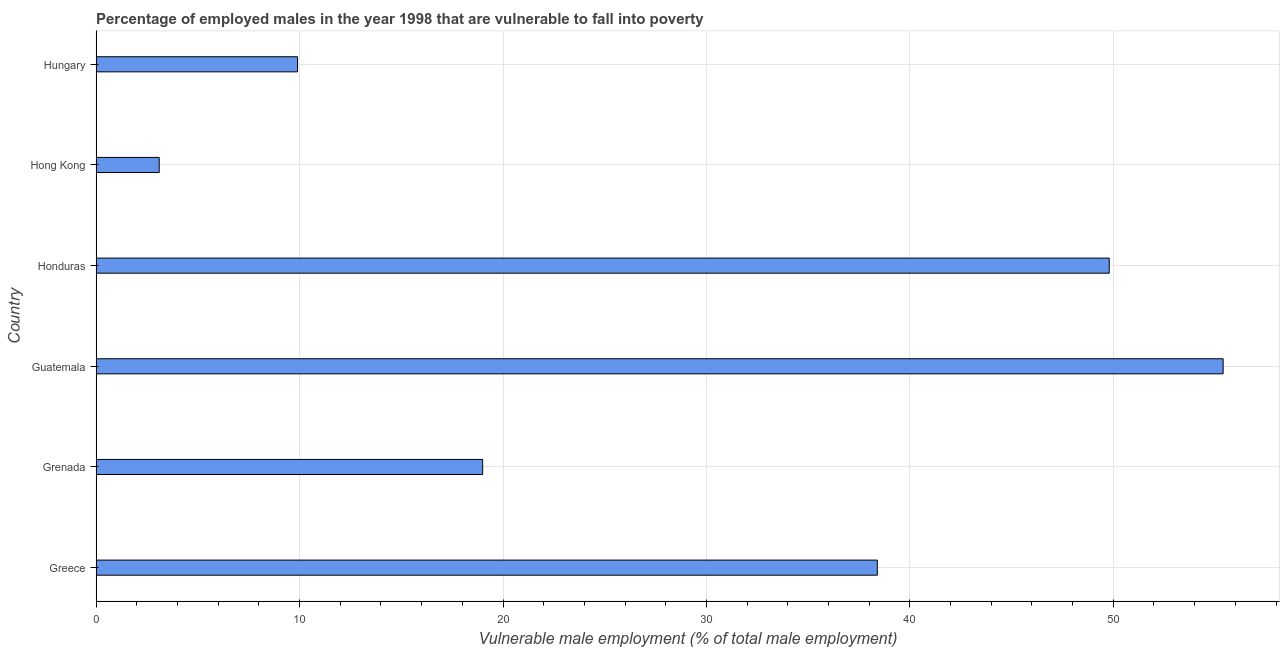Does the graph contain grids?
Offer a very short reply. Yes. What is the title of the graph?
Keep it short and to the point. Percentage of employed males in the year 1998 that are vulnerable to fall into poverty. What is the label or title of the X-axis?
Provide a short and direct response. Vulnerable male employment (% of total male employment). What is the percentage of employed males who are vulnerable to fall into poverty in Guatemala?
Offer a terse response. 55.4. Across all countries, what is the maximum percentage of employed males who are vulnerable to fall into poverty?
Provide a succinct answer. 55.4. Across all countries, what is the minimum percentage of employed males who are vulnerable to fall into poverty?
Make the answer very short. 3.1. In which country was the percentage of employed males who are vulnerable to fall into poverty maximum?
Provide a short and direct response. Guatemala. In which country was the percentage of employed males who are vulnerable to fall into poverty minimum?
Provide a succinct answer. Hong Kong. What is the sum of the percentage of employed males who are vulnerable to fall into poverty?
Provide a succinct answer. 175.6. What is the difference between the percentage of employed males who are vulnerable to fall into poverty in Grenada and Guatemala?
Make the answer very short. -36.4. What is the average percentage of employed males who are vulnerable to fall into poverty per country?
Your response must be concise. 29.27. What is the median percentage of employed males who are vulnerable to fall into poverty?
Keep it short and to the point. 28.7. In how many countries, is the percentage of employed males who are vulnerable to fall into poverty greater than 54 %?
Your answer should be compact. 1. What is the ratio of the percentage of employed males who are vulnerable to fall into poverty in Honduras to that in Hong Kong?
Provide a short and direct response. 16.07. What is the difference between the highest and the lowest percentage of employed males who are vulnerable to fall into poverty?
Give a very brief answer. 52.3. How many bars are there?
Keep it short and to the point. 6. Are all the bars in the graph horizontal?
Your answer should be very brief. Yes. How many countries are there in the graph?
Make the answer very short. 6. What is the Vulnerable male employment (% of total male employment) in Greece?
Offer a terse response. 38.4. What is the Vulnerable male employment (% of total male employment) in Guatemala?
Keep it short and to the point. 55.4. What is the Vulnerable male employment (% of total male employment) of Honduras?
Give a very brief answer. 49.8. What is the Vulnerable male employment (% of total male employment) of Hong Kong?
Ensure brevity in your answer.  3.1. What is the Vulnerable male employment (% of total male employment) of Hungary?
Make the answer very short. 9.9. What is the difference between the Vulnerable male employment (% of total male employment) in Greece and Guatemala?
Your response must be concise. -17. What is the difference between the Vulnerable male employment (% of total male employment) in Greece and Honduras?
Provide a short and direct response. -11.4. What is the difference between the Vulnerable male employment (% of total male employment) in Greece and Hong Kong?
Your answer should be compact. 35.3. What is the difference between the Vulnerable male employment (% of total male employment) in Grenada and Guatemala?
Provide a succinct answer. -36.4. What is the difference between the Vulnerable male employment (% of total male employment) in Grenada and Honduras?
Offer a very short reply. -30.8. What is the difference between the Vulnerable male employment (% of total male employment) in Grenada and Hong Kong?
Offer a very short reply. 15.9. What is the difference between the Vulnerable male employment (% of total male employment) in Guatemala and Honduras?
Ensure brevity in your answer.  5.6. What is the difference between the Vulnerable male employment (% of total male employment) in Guatemala and Hong Kong?
Make the answer very short. 52.3. What is the difference between the Vulnerable male employment (% of total male employment) in Guatemala and Hungary?
Provide a succinct answer. 45.5. What is the difference between the Vulnerable male employment (% of total male employment) in Honduras and Hong Kong?
Provide a short and direct response. 46.7. What is the difference between the Vulnerable male employment (% of total male employment) in Honduras and Hungary?
Your answer should be compact. 39.9. What is the ratio of the Vulnerable male employment (% of total male employment) in Greece to that in Grenada?
Provide a succinct answer. 2.02. What is the ratio of the Vulnerable male employment (% of total male employment) in Greece to that in Guatemala?
Provide a succinct answer. 0.69. What is the ratio of the Vulnerable male employment (% of total male employment) in Greece to that in Honduras?
Your answer should be very brief. 0.77. What is the ratio of the Vulnerable male employment (% of total male employment) in Greece to that in Hong Kong?
Make the answer very short. 12.39. What is the ratio of the Vulnerable male employment (% of total male employment) in Greece to that in Hungary?
Keep it short and to the point. 3.88. What is the ratio of the Vulnerable male employment (% of total male employment) in Grenada to that in Guatemala?
Offer a terse response. 0.34. What is the ratio of the Vulnerable male employment (% of total male employment) in Grenada to that in Honduras?
Provide a succinct answer. 0.38. What is the ratio of the Vulnerable male employment (% of total male employment) in Grenada to that in Hong Kong?
Your answer should be very brief. 6.13. What is the ratio of the Vulnerable male employment (% of total male employment) in Grenada to that in Hungary?
Make the answer very short. 1.92. What is the ratio of the Vulnerable male employment (% of total male employment) in Guatemala to that in Honduras?
Your answer should be compact. 1.11. What is the ratio of the Vulnerable male employment (% of total male employment) in Guatemala to that in Hong Kong?
Your answer should be compact. 17.87. What is the ratio of the Vulnerable male employment (% of total male employment) in Guatemala to that in Hungary?
Make the answer very short. 5.6. What is the ratio of the Vulnerable male employment (% of total male employment) in Honduras to that in Hong Kong?
Keep it short and to the point. 16.07. What is the ratio of the Vulnerable male employment (% of total male employment) in Honduras to that in Hungary?
Your answer should be compact. 5.03. What is the ratio of the Vulnerable male employment (% of total male employment) in Hong Kong to that in Hungary?
Your answer should be compact. 0.31. 